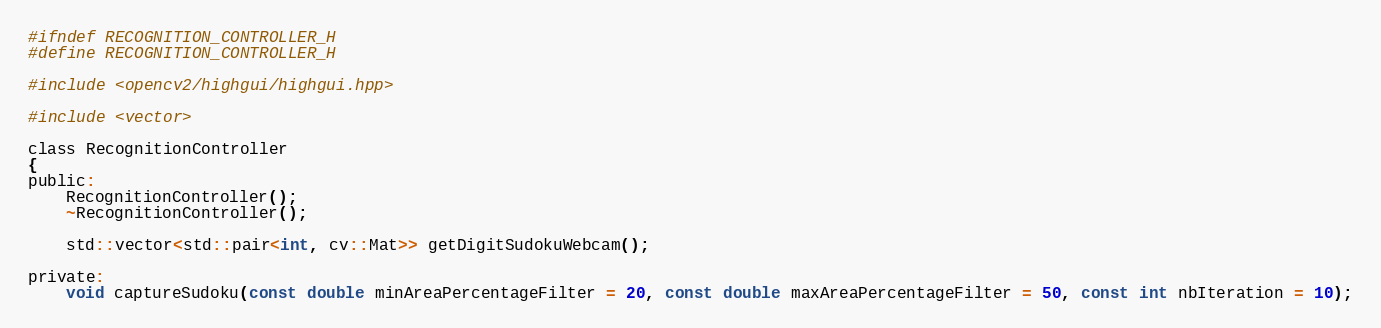Convert code to text. <code><loc_0><loc_0><loc_500><loc_500><_C_>#ifndef RECOGNITION_CONTROLLER_H
#define RECOGNITION_CONTROLLER_H

#include <opencv2/highgui/highgui.hpp>

#include <vector>

class RecognitionController
{
public:
	RecognitionController();
	~RecognitionController();

	std::vector<std::pair<int, cv::Mat>> getDigitSudokuWebcam();

private:
	void captureSudoku(const double minAreaPercentageFilter = 20, const double maxAreaPercentageFilter = 50, const int nbIteration = 10);</code> 